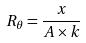<formula> <loc_0><loc_0><loc_500><loc_500>R _ { \theta } = \frac { x } { A \times k }</formula> 